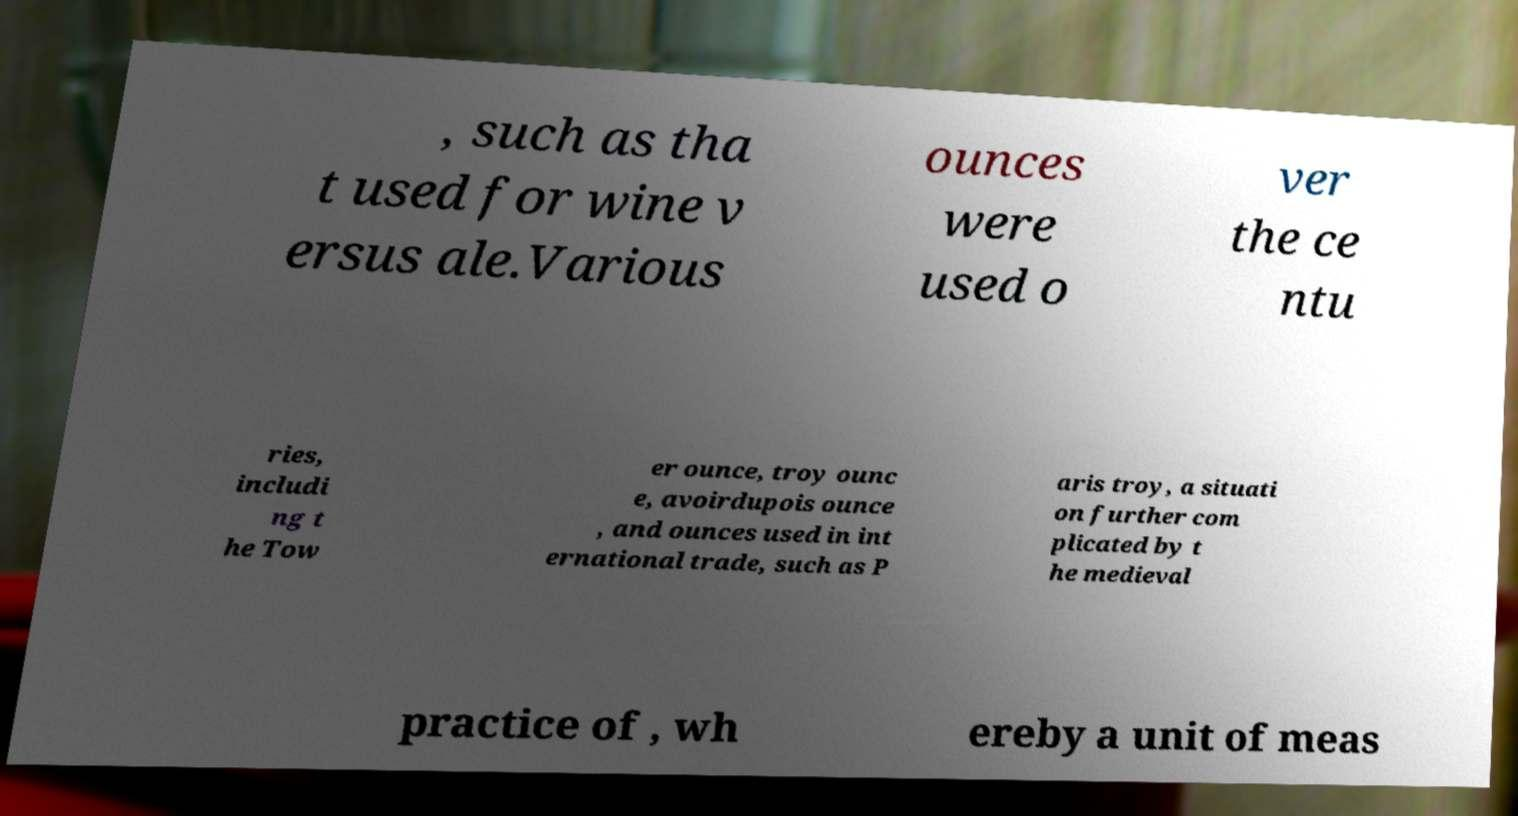What messages or text are displayed in this image? I need them in a readable, typed format. , such as tha t used for wine v ersus ale.Various ounces were used o ver the ce ntu ries, includi ng t he Tow er ounce, troy ounc e, avoirdupois ounce , and ounces used in int ernational trade, such as P aris troy, a situati on further com plicated by t he medieval practice of , wh ereby a unit of meas 